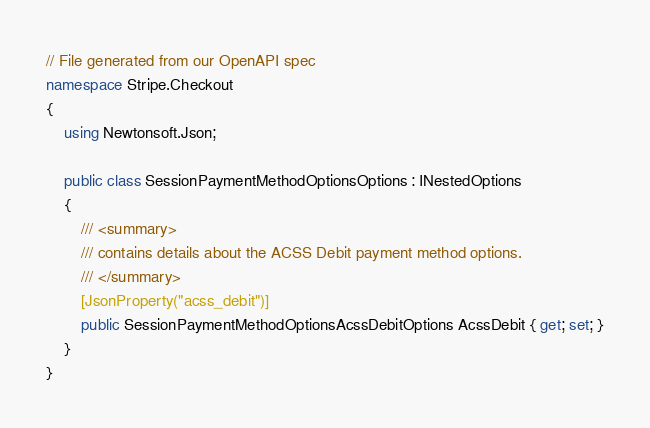Convert code to text. <code><loc_0><loc_0><loc_500><loc_500><_C#_>// File generated from our OpenAPI spec
namespace Stripe.Checkout
{
    using Newtonsoft.Json;

    public class SessionPaymentMethodOptionsOptions : INestedOptions
    {
        /// <summary>
        /// contains details about the ACSS Debit payment method options.
        /// </summary>
        [JsonProperty("acss_debit")]
        public SessionPaymentMethodOptionsAcssDebitOptions AcssDebit { get; set; }
    }
}
</code> 